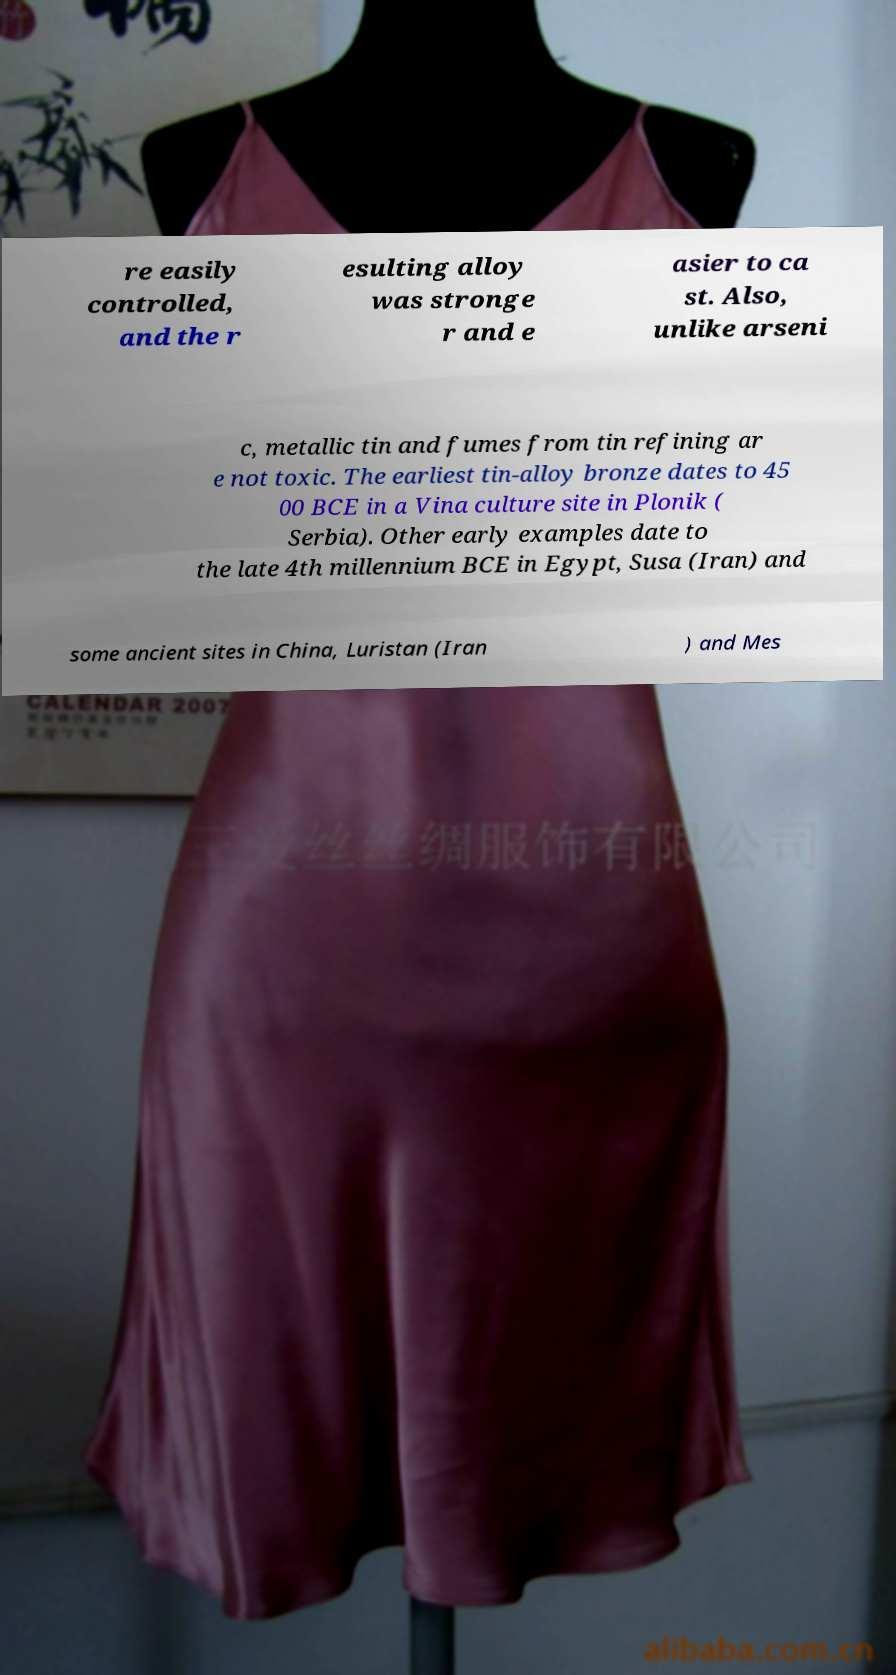Please identify and transcribe the text found in this image. re easily controlled, and the r esulting alloy was stronge r and e asier to ca st. Also, unlike arseni c, metallic tin and fumes from tin refining ar e not toxic. The earliest tin-alloy bronze dates to 45 00 BCE in a Vina culture site in Plonik ( Serbia). Other early examples date to the late 4th millennium BCE in Egypt, Susa (Iran) and some ancient sites in China, Luristan (Iran ) and Mes 